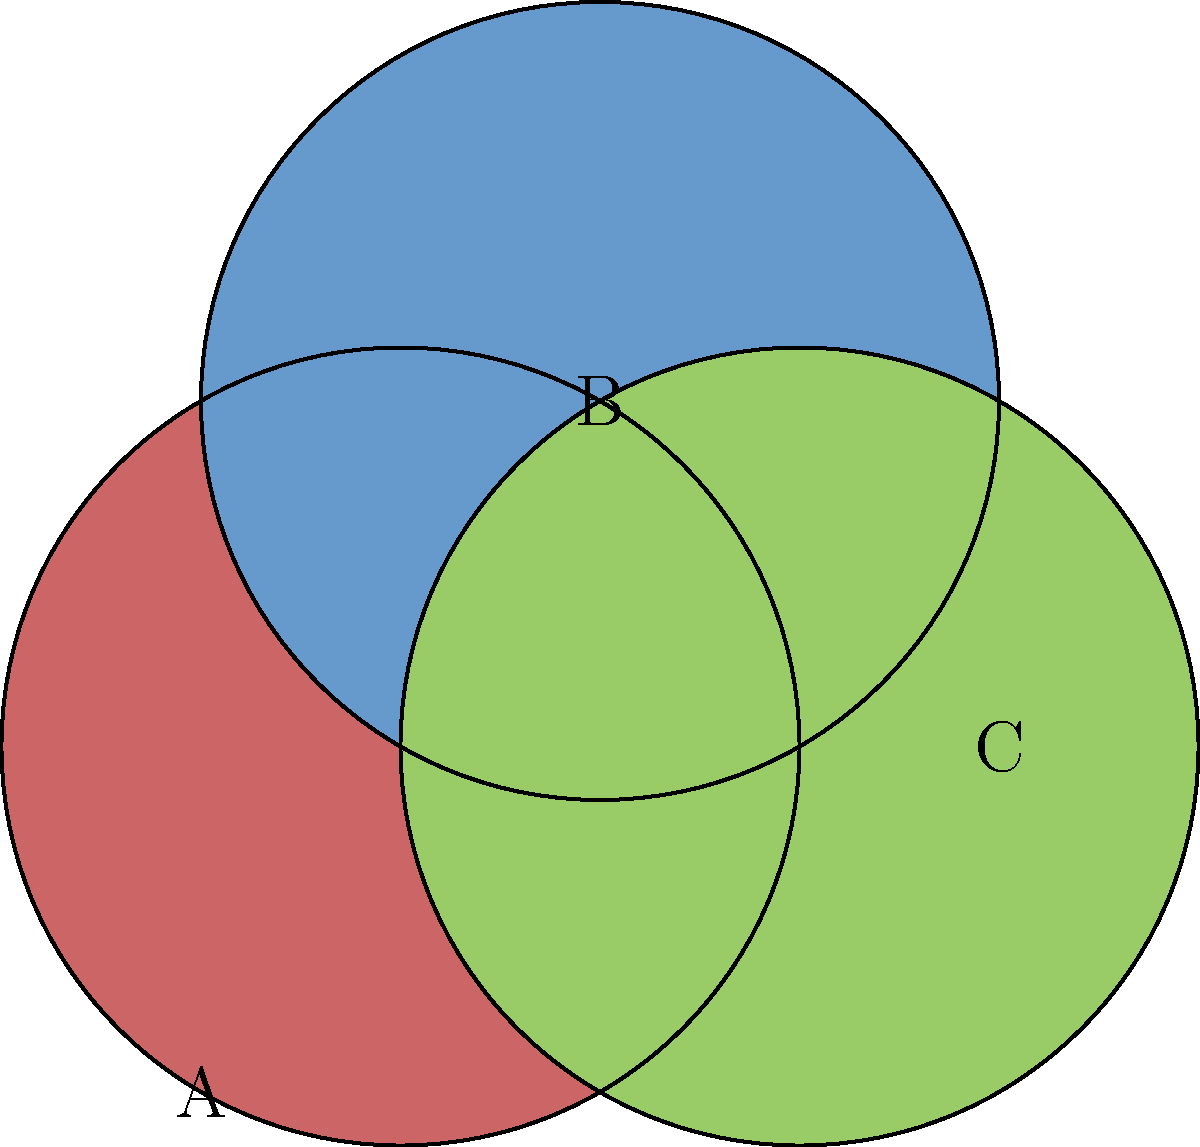Consider the diagram of three interlocking circles, each representing a distinct emotion in the tapestry of human experience. If we apply a clockwise rotation of 120° to this configuration around the center point where all circles intersect, what is the order of this rotation in the context of group theory? How does this relate to the cyclic nature of unexpressed emotions? To determine the order of the rotation in group theory, we need to follow these steps:

1. Understand the rotation:
   A 120° clockwise rotation moves each circle to the position of another.

2. Observe the cycle:
   A → B → C → A

3. Determine the number of rotations needed to return to the original state:
   - 1st rotation (120°): A → B, B → C, C → A
   - 2nd rotation (240°): A → C, B → A, C → B
   - 3rd rotation (360°): A → A, B → B, C → C

4. Calculate the order:
   The order of an element in group theory is the smallest positive integer $n$ such that $g^n = e$, where $e$ is the identity element.
   In this case, it takes 3 rotations to return to the original configuration.

5. Interpret the result:
   The order of this rotation is 3, forming a cyclic group of order 3, denoted as $C_3$ or $\mathbb{Z}_3$.

6. Relation to unexpressed emotions:
   This cyclic nature mirrors the way unexpressed emotions often rotate through our consciousness, each taking precedence before giving way to another, only to return again in a continuous cycle of introspection and emotional evolution.
Answer: 3 